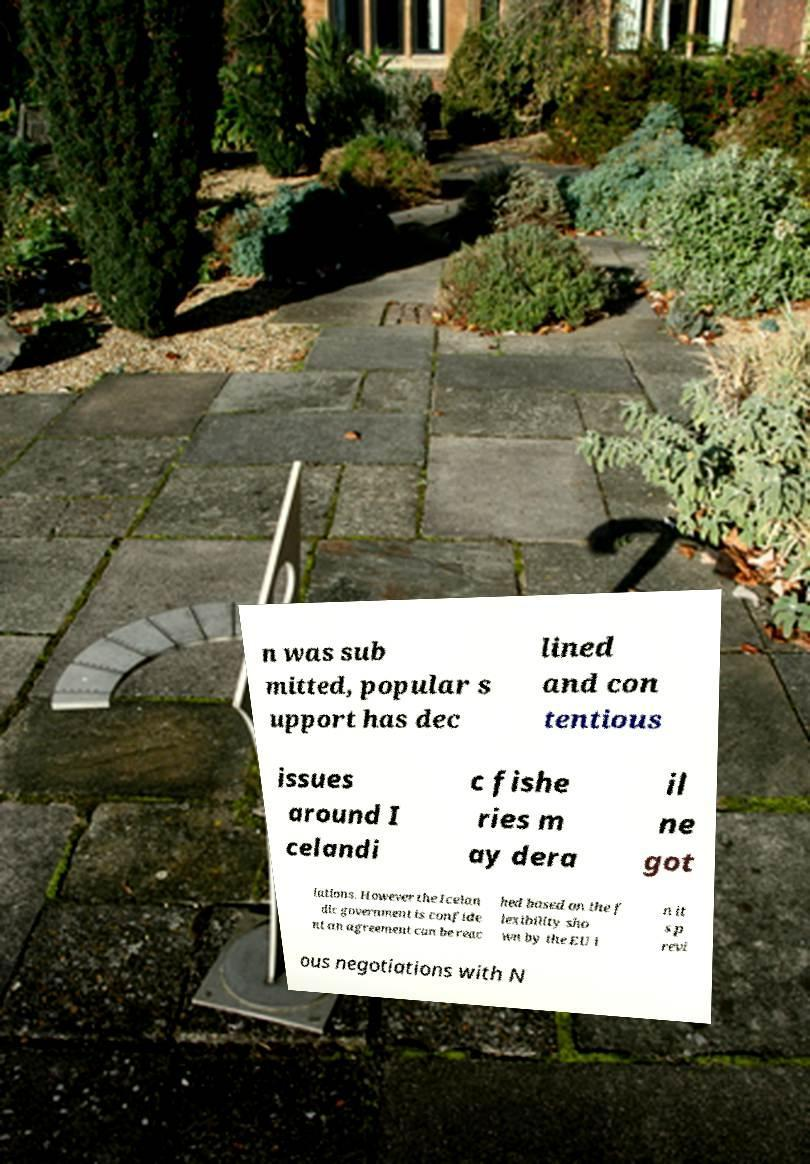I need the written content from this picture converted into text. Can you do that? n was sub mitted, popular s upport has dec lined and con tentious issues around I celandi c fishe ries m ay dera il ne got iations. However the Icelan dic government is confide nt an agreement can be reac hed based on the f lexibility sho wn by the EU i n it s p revi ous negotiations with N 